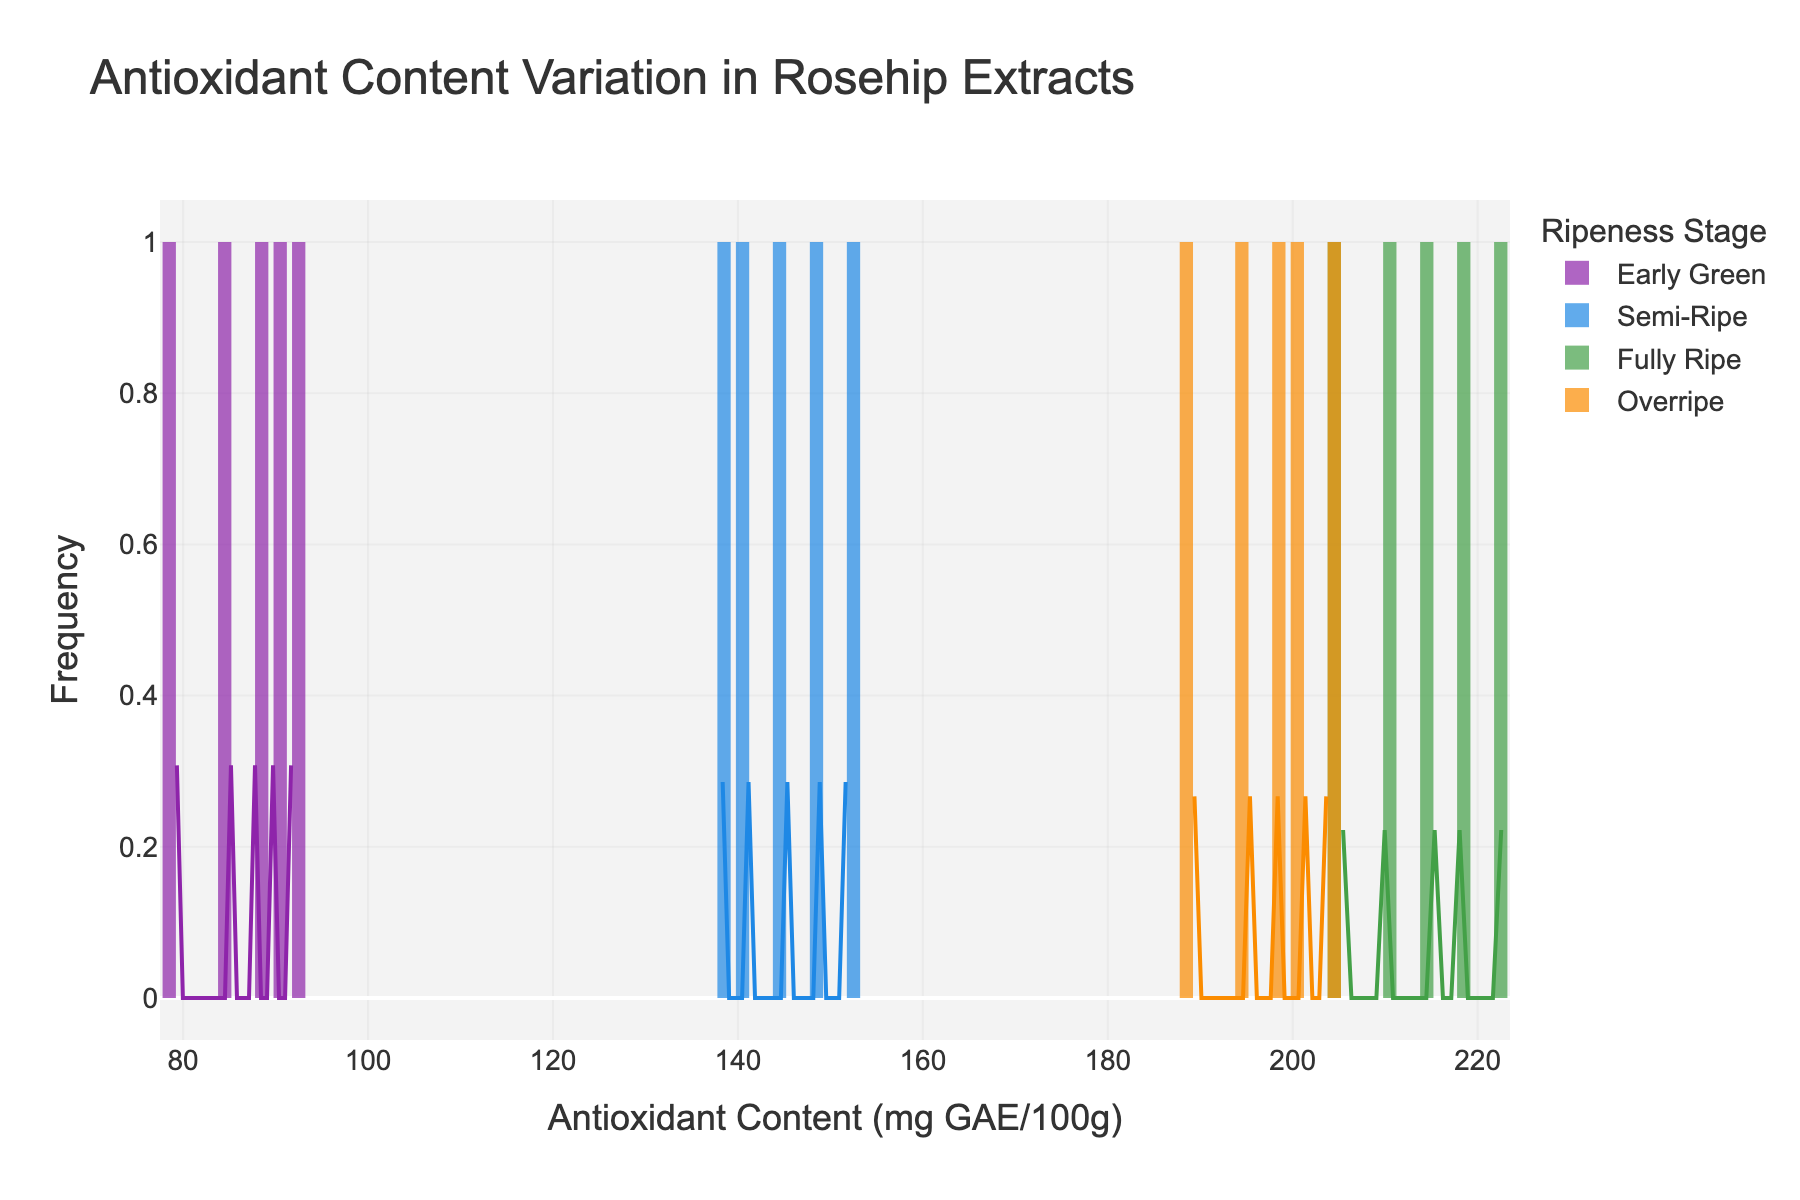What is the title of the figure? The title of the figure is 'Antioxidant Content Variation in Rosehip Extracts.' This can be seen at the top of the figure.
Answer: Antioxidant Content Variation in Rosehip Extracts What is the unit of measurement for the x-axis? The x-axis is labeled 'Antioxidant Content (mg GAE/100g).' This indicates that the unit of measurement is milligrams of Gallic Acid Equivalents per 100 grams.
Answer: mg GAE/100g Which ripeness stage shows the highest antioxidant content on average? By observing the histogram, the 'Fully Ripe' stage has the highest antioxidant content on average because its histogram bars are centered around higher values compared to other stages.
Answer: Fully Ripe How do the histogram distributions of 'Semi-Ripe' and 'Overripe' stages compare? The 'Semi-Ripe' histogram is centered around 140-150 mg GAE/100g and has a smaller range of values, while the 'Overripe' histogram is centered around 195-205 mg GAE/100g, showing a slight decrease from the 'Fully Ripe' stage.
Answer: 'Semi-Ripe' is lower and more narrow, 'Overripe' is higher but slightly less than 'Fully Ripe' What is the color used to represent the 'Early Green' ripeness stage? The 'Early Green' ripeness stage is represented by the color purple in the histogram.
Answer: Purple Which ripeness stage has the most overlap with another stage based on the KDE curves? The 'Fully Ripe' and 'Overripe' stages have KDE curves that overlap significantly, indicating similar distributions in antioxidant content.
Answer: Fully Ripe and Overripe What is the range of antioxidant contents for the 'Early Green' stage? The histogram bars for the 'Early Green' stage span from around 79 to 92 mg GAE/100g, indicating the range of antioxidant contents in this ripeness stage.
Answer: 79 to 92 mg GAE/100g Compare the density peaks of 'Early Green' and 'Fully Ripe' stages. Which one is higher? The density peak (KDE curve peak) for the 'Fully Ripe' stage is higher than that of the 'Early Green' stage, showing that 'Fully Ripe' has a higher concentration of values around the mean.
Answer: Fully Ripe By how much does the average antioxidant content of the 'Semi-Ripe' stage exceed that of the 'Early Green' stage? The average antioxidant content for 'Semi-Ripe' is around 145 mg GAE/100g, and for 'Early Green', it is around 87 mg GAE/100g. The difference is therefore 145 - 87 = 58 mg GAE/100g.
Answer: 58 mg GAE/100g 